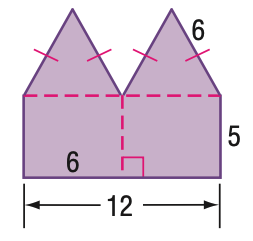Question: Find the area of the figure. Round to the nearest tenth.
Choices:
A. 75.6
B. 91.2
C. 96
D. 101.6
Answer with the letter. Answer: B 